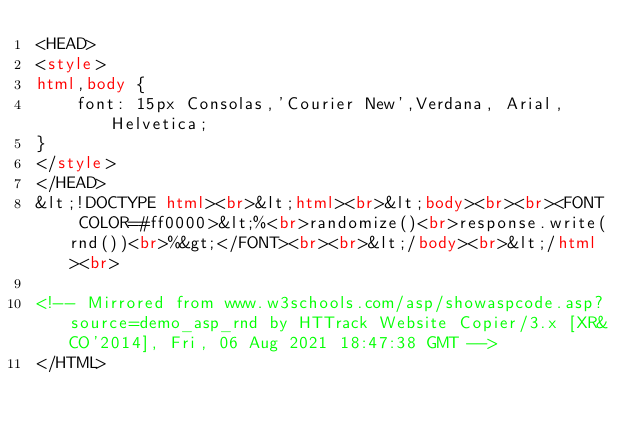Convert code to text. <code><loc_0><loc_0><loc_500><loc_500><_HTML_><HEAD>
<style>
html,body {
    font: 15px Consolas,'Courier New',Verdana, Arial, Helvetica;
}
</style>
</HEAD>
&lt;!DOCTYPE html><br>&lt;html><br>&lt;body><br><br><FONT COLOR=#ff0000>&lt;%<br>randomize()<br>response.write(rnd())<br>%&gt;</FONT><br><br>&lt;/body><br>&lt;/html><br>

<!-- Mirrored from www.w3schools.com/asp/showaspcode.asp?source=demo_asp_rnd by HTTrack Website Copier/3.x [XR&CO'2014], Fri, 06 Aug 2021 18:47:38 GMT -->
</HTML>
</code> 